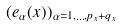<formula> <loc_0><loc_0><loc_500><loc_500>( e _ { \alpha } ( x ) ) _ { \alpha = 1 , \dots , p _ { x } + q _ { x } }</formula> 